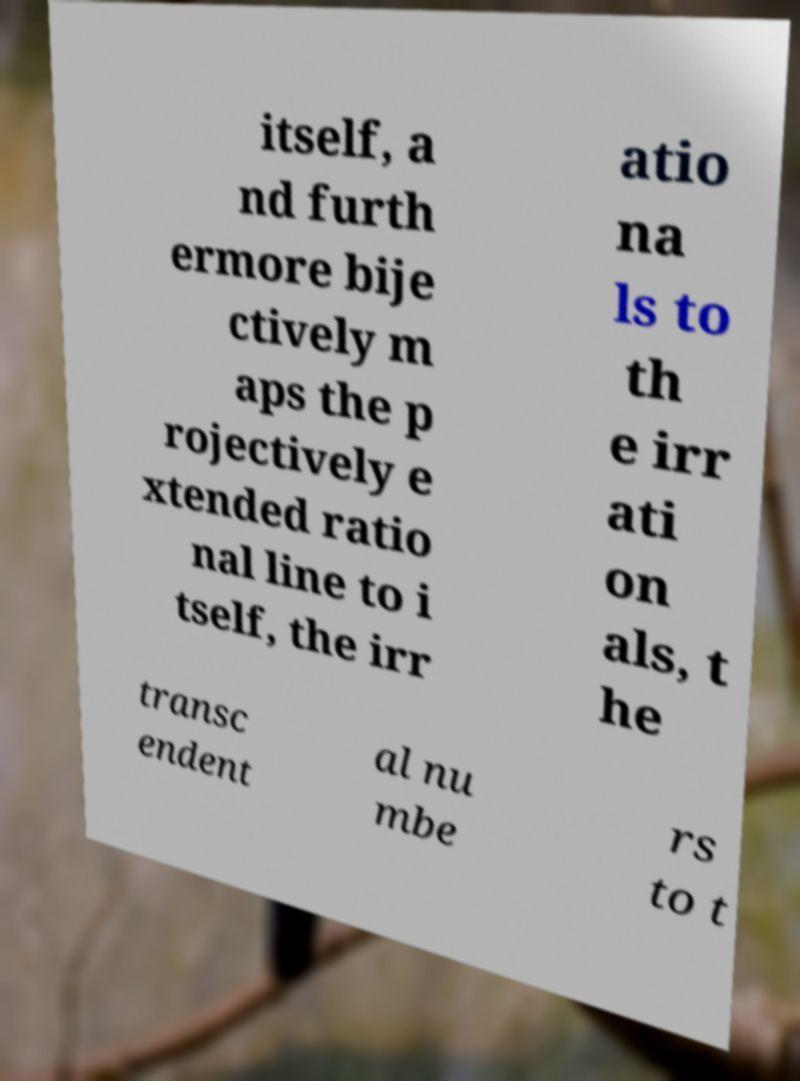Can you read and provide the text displayed in the image?This photo seems to have some interesting text. Can you extract and type it out for me? itself, a nd furth ermore bije ctively m aps the p rojectively e xtended ratio nal line to i tself, the irr atio na ls to th e irr ati on als, t he transc endent al nu mbe rs to t 